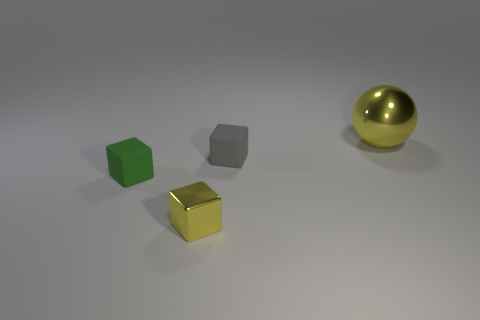Add 4 big blue metal blocks. How many objects exist? 8 Subtract all spheres. How many objects are left? 3 Subtract all big yellow metal balls. Subtract all metal objects. How many objects are left? 1 Add 3 small yellow cubes. How many small yellow cubes are left? 4 Add 2 matte cubes. How many matte cubes exist? 4 Subtract 0 gray cylinders. How many objects are left? 4 